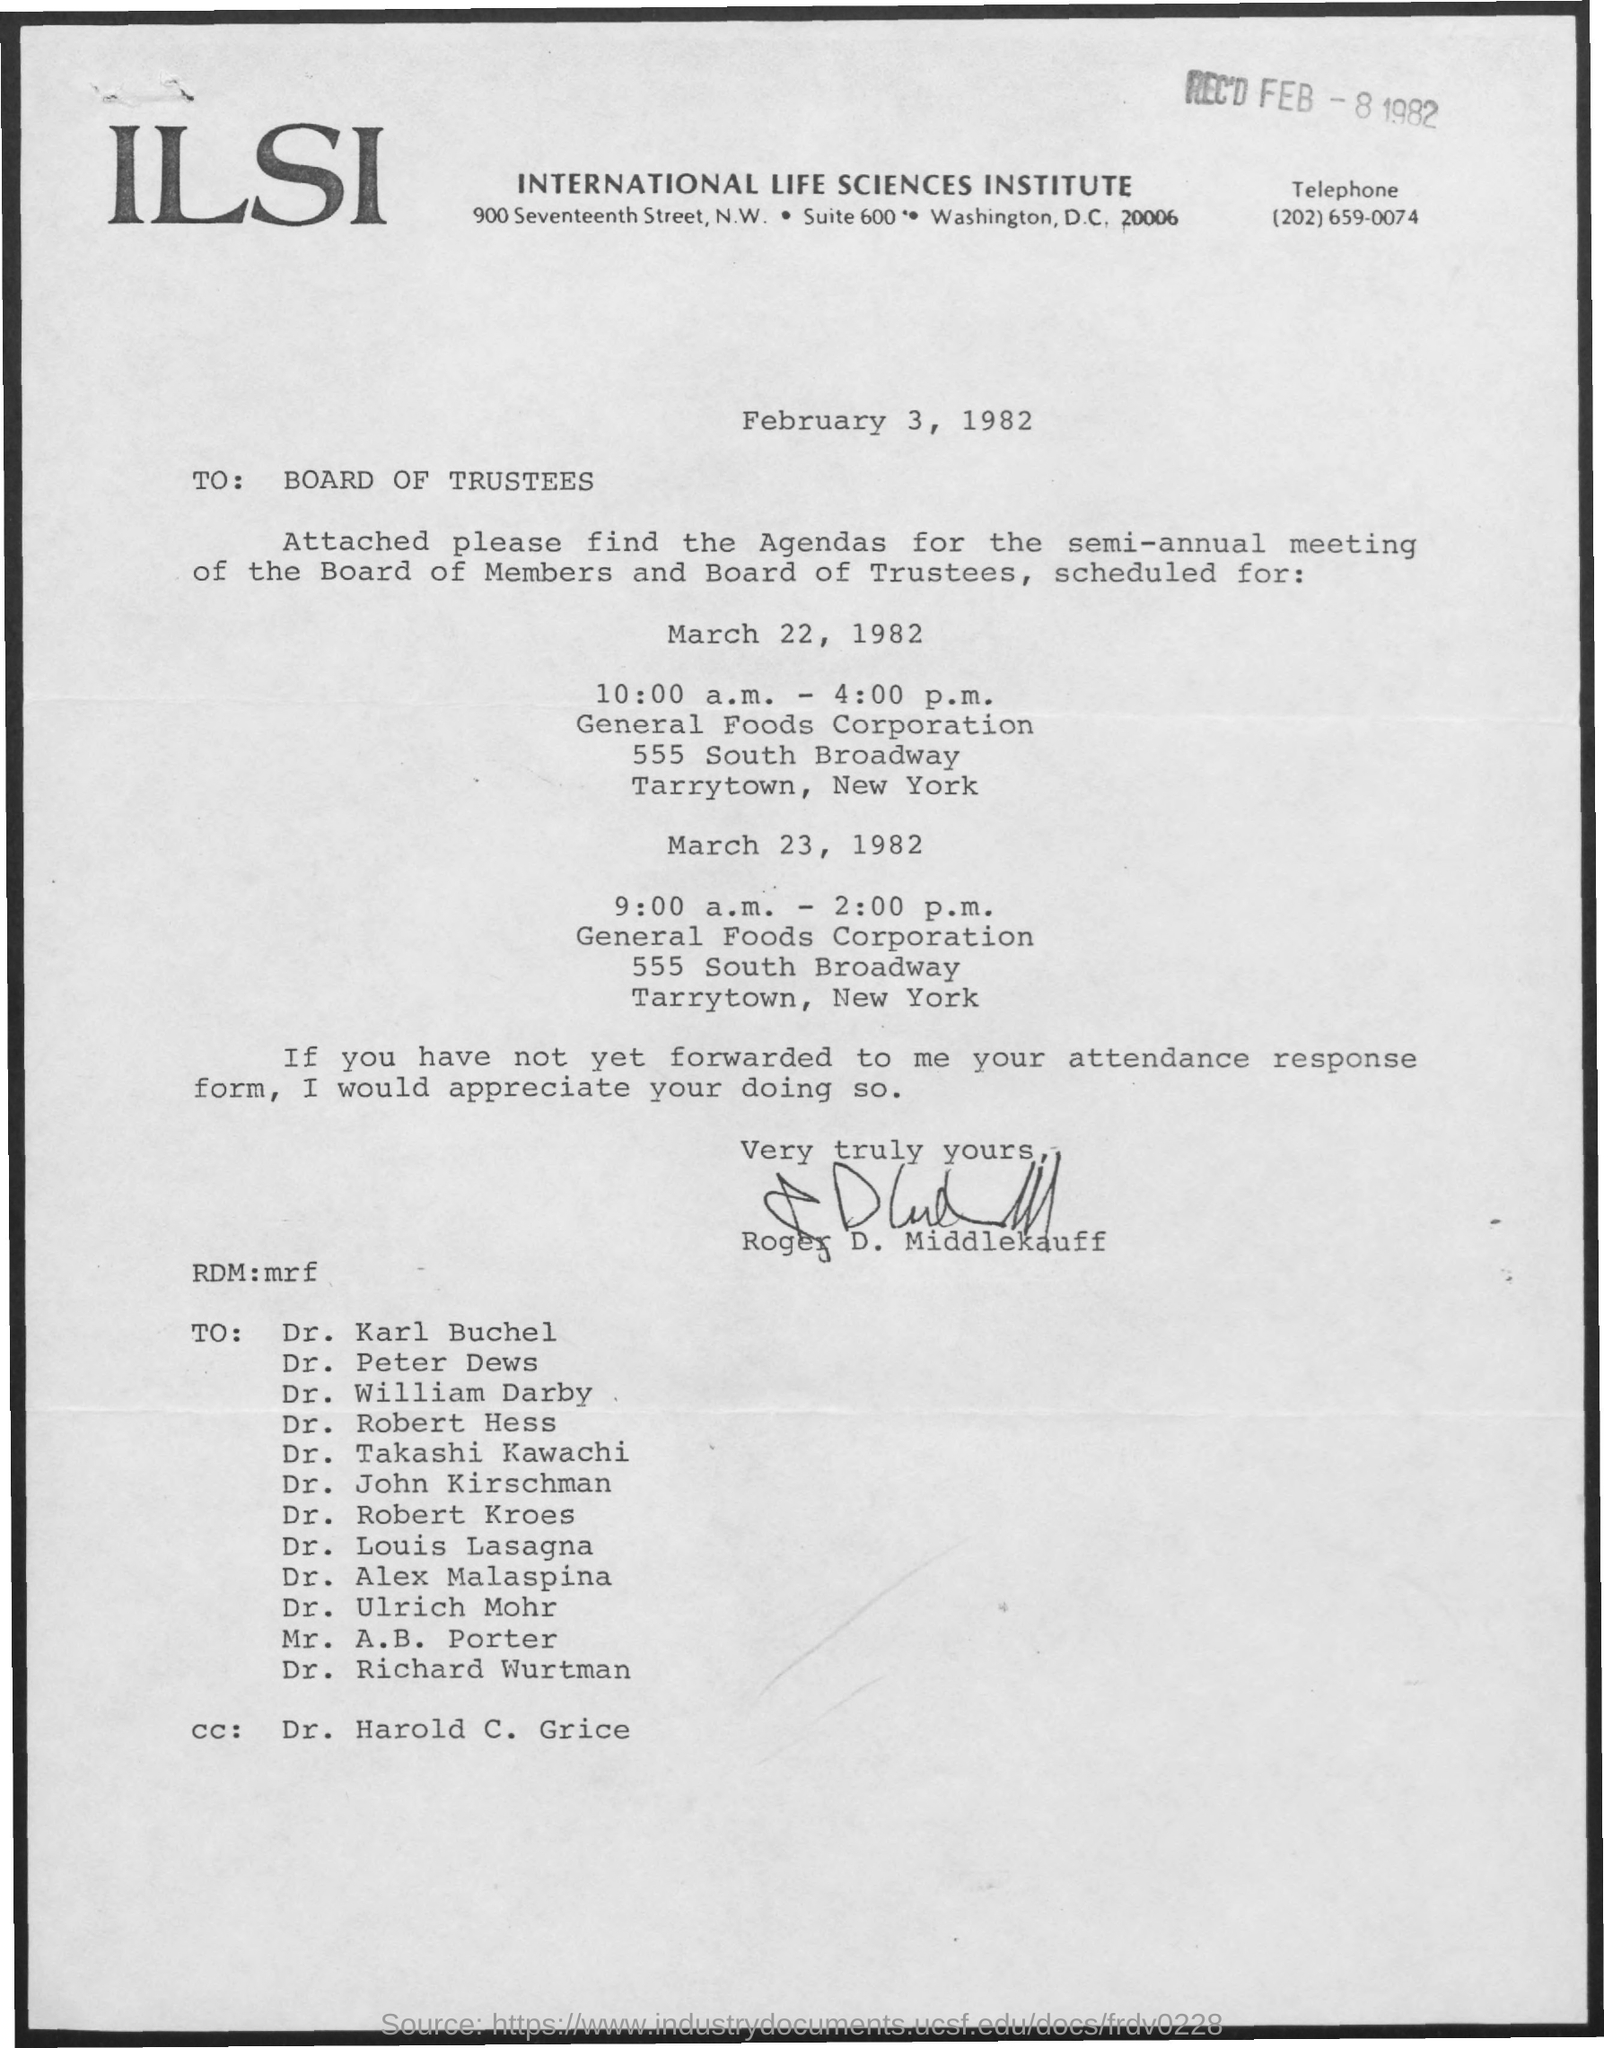Which institution is mentioned?
Provide a succinct answer. INTERNATIONAL LIFE SCIENCES INSTITUTE. When was the document received?
Your response must be concise. FEB - 8 1982. When is the document dated?
Make the answer very short. February 3, 1982. To whom is the document addressed?
Your answer should be very brief. Board of Trustees. Who has signed the letter?
Provide a short and direct response. Roger d. middlekauff. To whom is the cc?
Ensure brevity in your answer.  Dr. harold c. grice. 